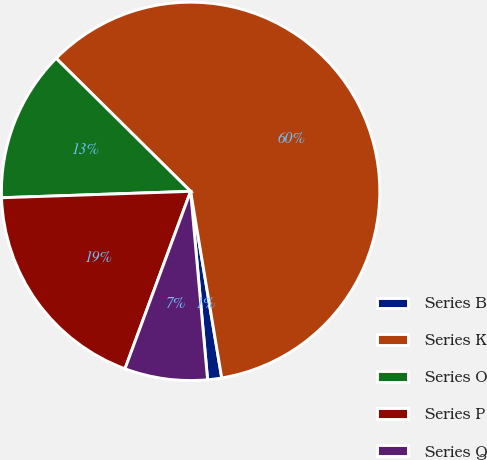Convert chart to OTSL. <chart><loc_0><loc_0><loc_500><loc_500><pie_chart><fcel>Series B<fcel>Series K<fcel>Series O<fcel>Series P<fcel>Series Q<nl><fcel>1.2%<fcel>59.95%<fcel>12.95%<fcel>18.82%<fcel>7.07%<nl></chart> 